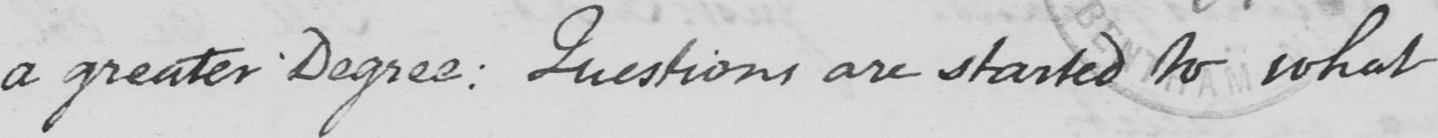What is written in this line of handwriting? a greater Degree :  Questions are started to what 